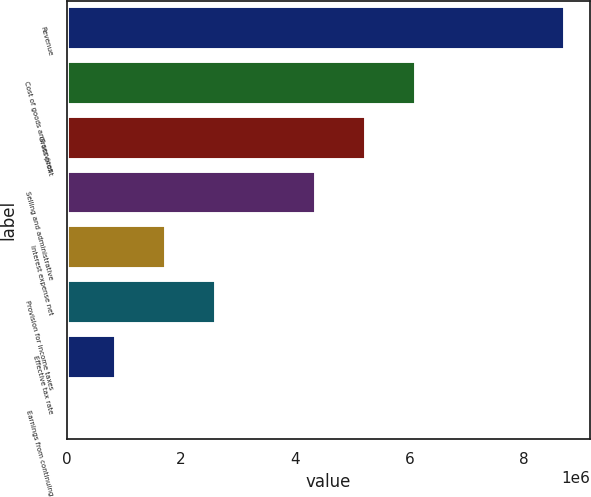Convert chart. <chart><loc_0><loc_0><loc_500><loc_500><bar_chart><fcel>Revenue<fcel>Cost of goods and services<fcel>Gross profit<fcel>Selling and administrative<fcel>Interest expense net<fcel>Provision for income taxes<fcel>Effective tax rate<fcel>Earnings from continuing<nl><fcel>8.72981e+06<fcel>6.11087e+06<fcel>5.23789e+06<fcel>4.36491e+06<fcel>1.74597e+06<fcel>2.61895e+06<fcel>872986<fcel>5.57<nl></chart> 